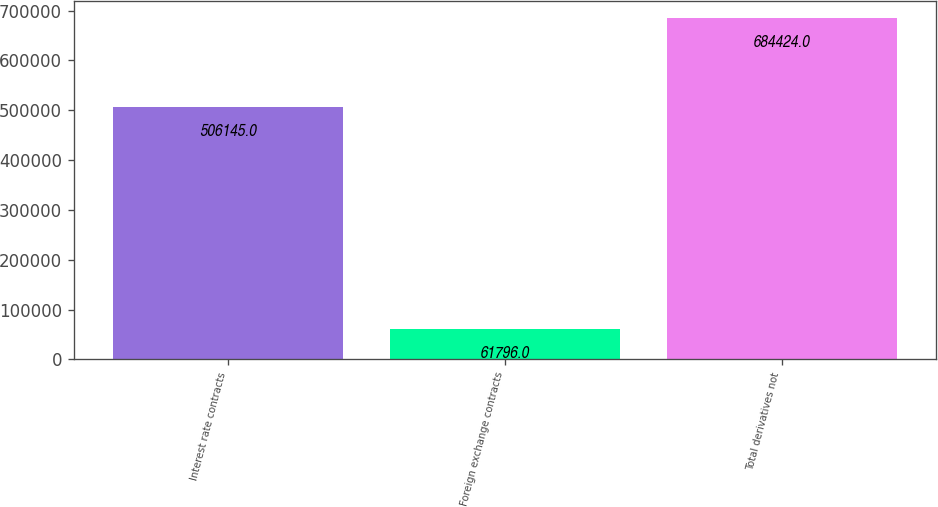Convert chart. <chart><loc_0><loc_0><loc_500><loc_500><bar_chart><fcel>Interest rate contracts<fcel>Foreign exchange contracts<fcel>Total derivatives not<nl><fcel>506145<fcel>61796<fcel>684424<nl></chart> 